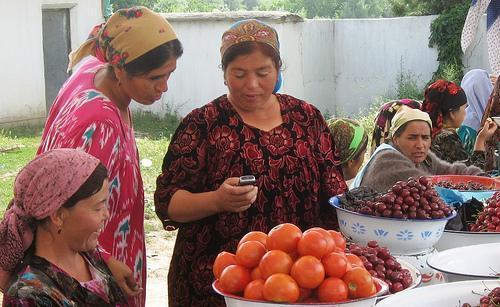How many bowls can you see?
Give a very brief answer. 4. How many people are there?
Give a very brief answer. 5. How many cups are empty on the table?
Give a very brief answer. 0. 